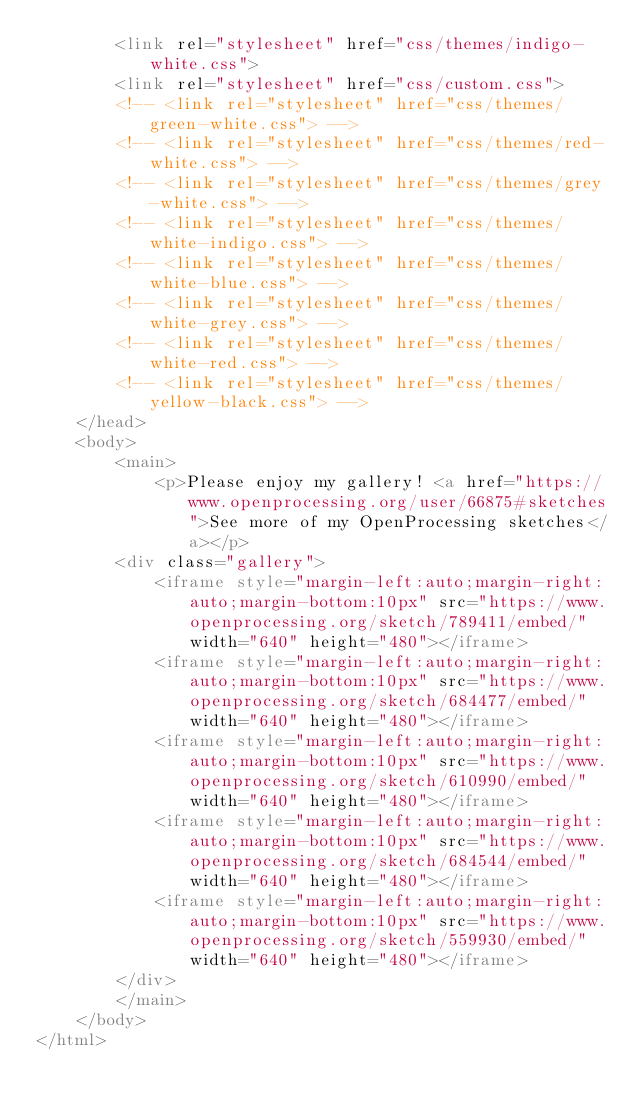Convert code to text. <code><loc_0><loc_0><loc_500><loc_500><_HTML_>        <link rel="stylesheet" href="css/themes/indigo-white.css">
        <link rel="stylesheet" href="css/custom.css">
        <!-- <link rel="stylesheet" href="css/themes/green-white.css"> -->
        <!-- <link rel="stylesheet" href="css/themes/red-white.css"> -->
        <!-- <link rel="stylesheet" href="css/themes/grey-white.css"> -->
        <!-- <link rel="stylesheet" href="css/themes/white-indigo.css"> -->
        <!-- <link rel="stylesheet" href="css/themes/white-blue.css"> -->
        <!-- <link rel="stylesheet" href="css/themes/white-grey.css"> -->
        <!-- <link rel="stylesheet" href="css/themes/white-red.css"> -->
        <!-- <link rel="stylesheet" href="css/themes/yellow-black.css"> -->
    </head>
    <body>
        <main>
            <p>Please enjoy my gallery! <a href="https://www.openprocessing.org/user/66875#sketches">See more of my OpenProcessing sketches</a></p>
        <div class="gallery">
            <iframe style="margin-left:auto;margin-right:auto;margin-bottom:10px" src="https://www.openprocessing.org/sketch/789411/embed/" width="640" height="480"></iframe>
            <iframe style="margin-left:auto;margin-right:auto;margin-bottom:10px" src="https://www.openprocessing.org/sketch/684477/embed/" width="640" height="480"></iframe>
            <iframe style="margin-left:auto;margin-right:auto;margin-bottom:10px" src="https://www.openprocessing.org/sketch/610990/embed/" width="640" height="480"></iframe>
            <iframe style="margin-left:auto;margin-right:auto;margin-bottom:10px" src="https://www.openprocessing.org/sketch/684544/embed/" width="640" height="480"></iframe>
            <iframe style="margin-left:auto;margin-right:auto;margin-bottom:10px" src="https://www.openprocessing.org/sketch/559930/embed/" width="640" height="480"></iframe>
        </div>
        </main>
    </body>
</html>
</code> 